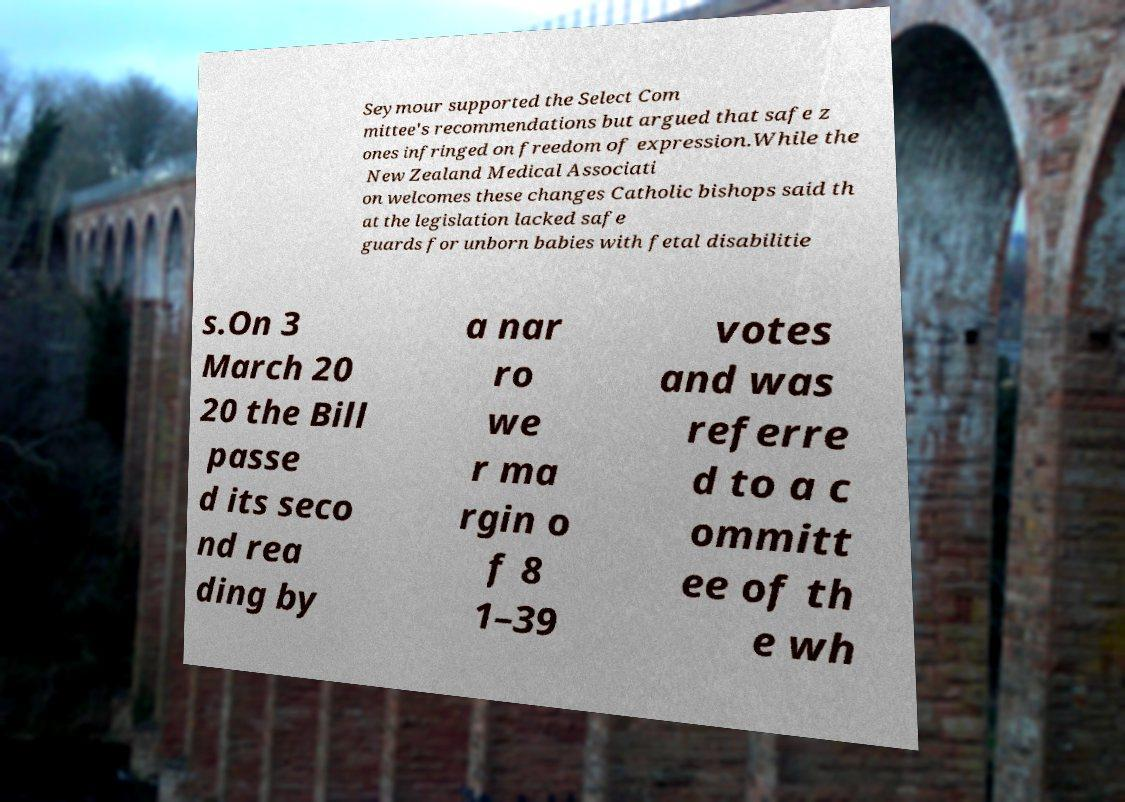What messages or text are displayed in this image? I need them in a readable, typed format. Seymour supported the Select Com mittee's recommendations but argued that safe z ones infringed on freedom of expression.While the New Zealand Medical Associati on welcomes these changes Catholic bishops said th at the legislation lacked safe guards for unborn babies with fetal disabilitie s.On 3 March 20 20 the Bill passe d its seco nd rea ding by a nar ro we r ma rgin o f 8 1–39 votes and was referre d to a c ommitt ee of th e wh 